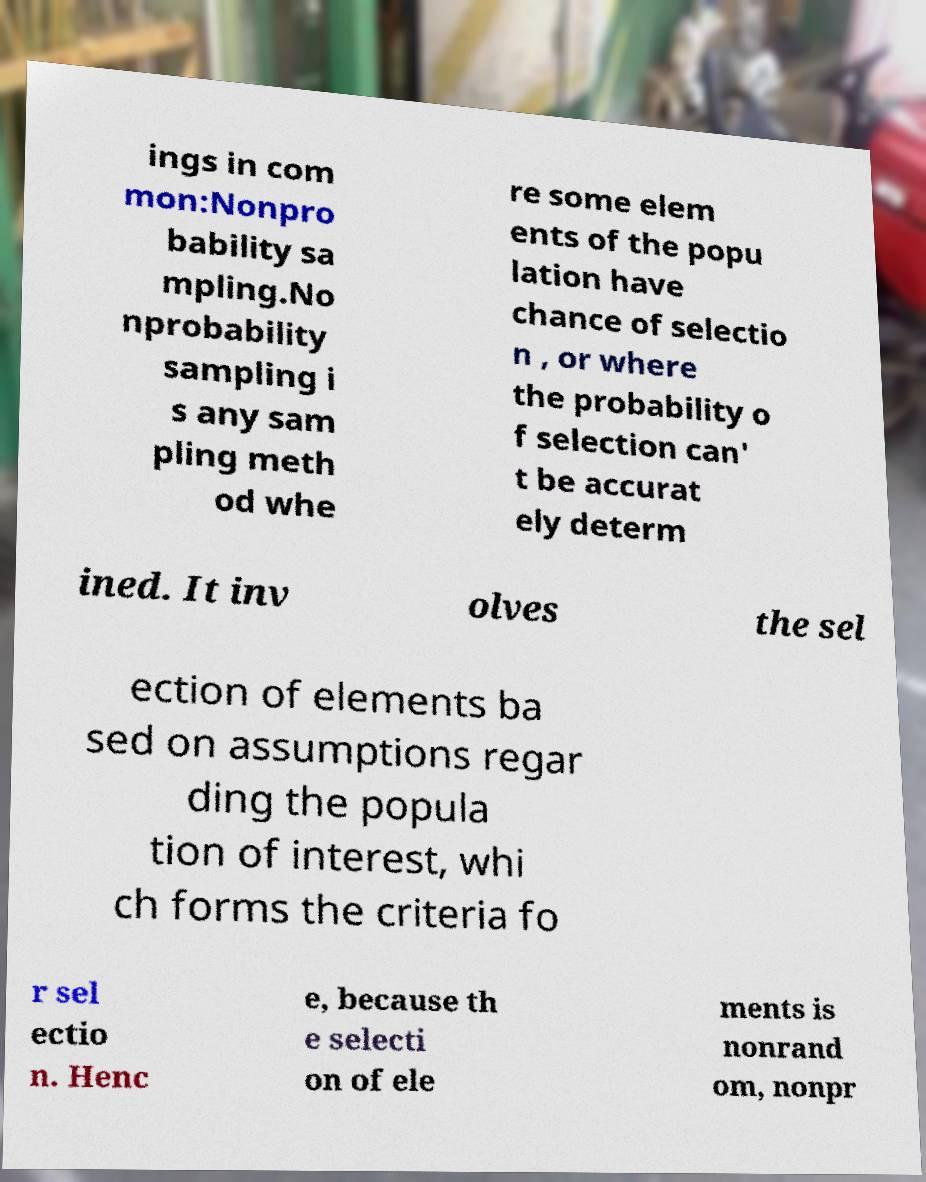Could you assist in decoding the text presented in this image and type it out clearly? ings in com mon:Nonpro bability sa mpling.No nprobability sampling i s any sam pling meth od whe re some elem ents of the popu lation have chance of selectio n , or where the probability o f selection can' t be accurat ely determ ined. It inv olves the sel ection of elements ba sed on assumptions regar ding the popula tion of interest, whi ch forms the criteria fo r sel ectio n. Henc e, because th e selecti on of ele ments is nonrand om, nonpr 